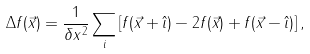<formula> <loc_0><loc_0><loc_500><loc_500>\Delta f ( \vec { x } ) = \frac { 1 } { \delta x ^ { 2 } } \sum _ { i } \left [ f ( \vec { x } + \hat { \imath } ) - 2 f ( \vec { x } ) + f ( \vec { x } - \hat { \imath } ) \right ] ,</formula> 